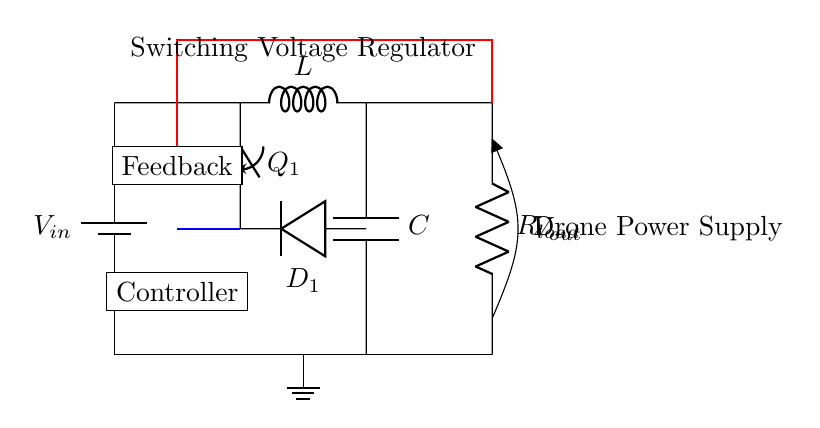What is the input voltage of this circuit? The input voltage is indicated as V_in near the battery symbol at the left of the circuit.
Answer: V_in What does L represent in the circuit? L stands for an inductor, which is a component that stores energy in a magnetic field when electric current passes through it. This can be found in the component label in the circuit diagram.
Answer: Inductor What component provides feedback to the controller? The feedback in the circuit is taken from the output voltage line (V_out) and is represented by the red line connecting to the controller label, indicating that it is used to control the regulator's output.
Answer: Feedback What is the function of the switch in this circuit? The switch (labeled Q_1) controls the flow of current through the circuit. When closed, it allows current to flow through the inductor and capacitor, affecting the output voltage. Its position can be seen at the top of the diagram, connecting the input and the inductor.
Answer: Controls current flow How does this circuit type regulate voltage output? This switching voltage regulator adjusts the output voltage by rapidly opening and closing the switch Q_1, which allows energy to be stored in the inductor L and released to the load (R_load) through the diode D_1. The feedback loop also helps maintain a stable output voltage by adjusting the duty cycle of the switch based on V_out.
Answer: Adjusts duty cycle What is the output load resistor labeled as in the circuit? The load resistor in the circuit is labeled as R_load on the right side of the diagram, indicating where the output voltage is applied or drawn from, to supply power to the drone.
Answer: R_load 